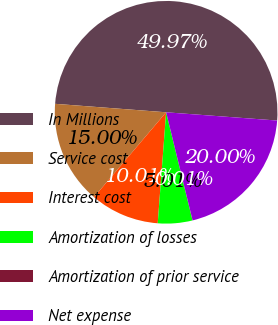Convert chart to OTSL. <chart><loc_0><loc_0><loc_500><loc_500><pie_chart><fcel>In Millions<fcel>Service cost<fcel>Interest cost<fcel>Amortization of losses<fcel>Amortization of prior service<fcel>Net expense<nl><fcel>49.97%<fcel>15.0%<fcel>10.01%<fcel>5.01%<fcel>0.01%<fcel>20.0%<nl></chart> 